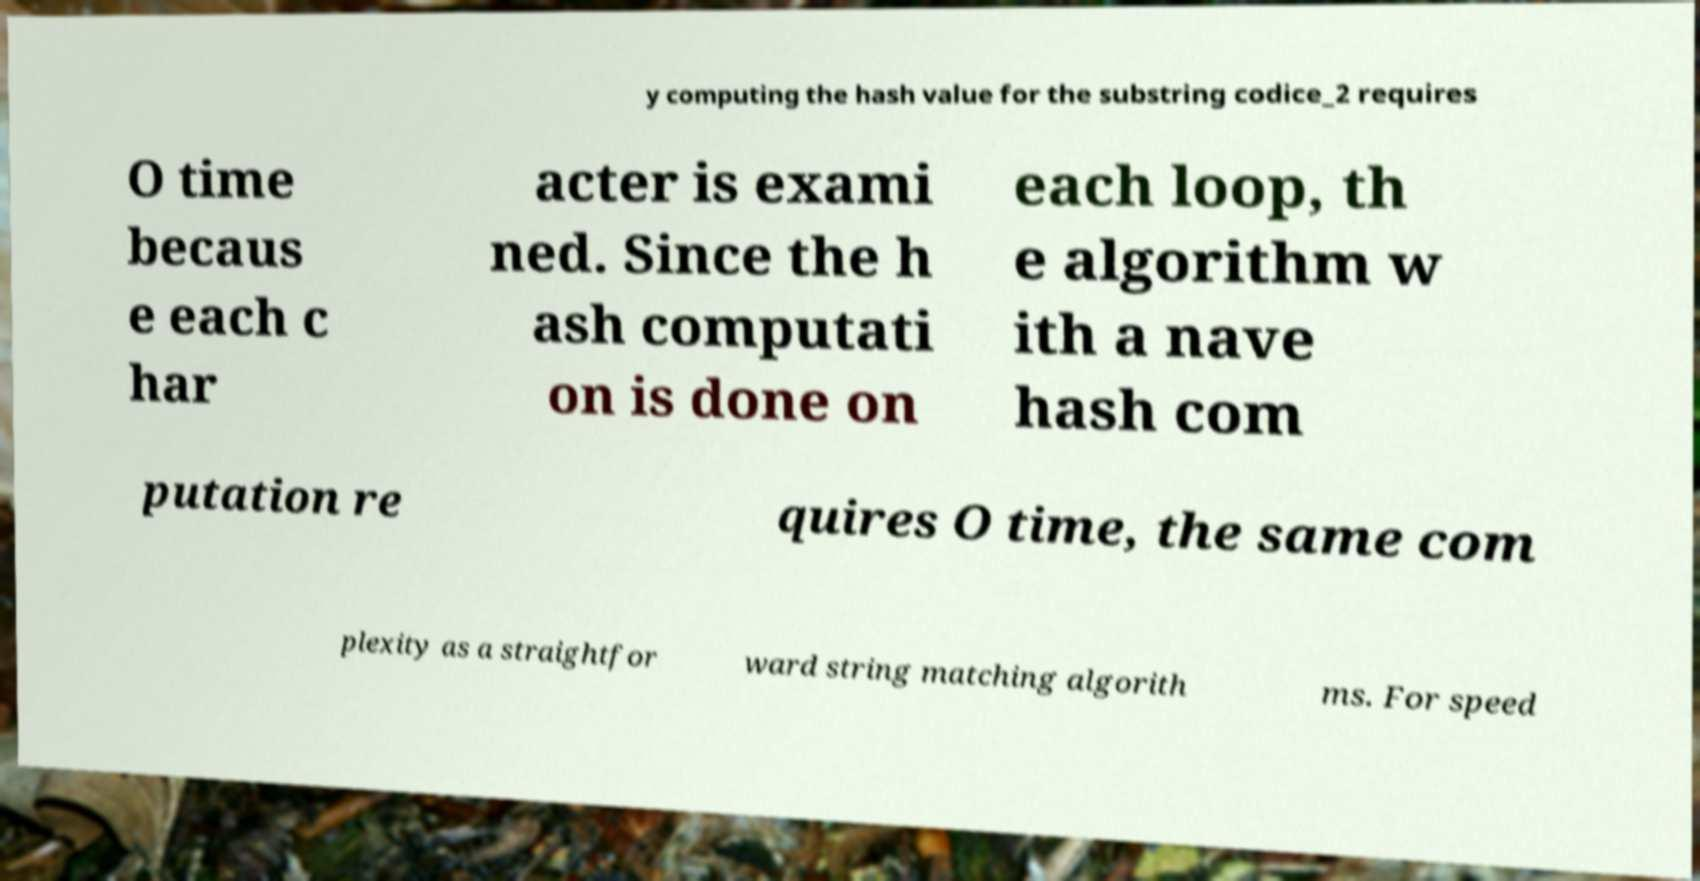Could you assist in decoding the text presented in this image and type it out clearly? y computing the hash value for the substring codice_2 requires O time becaus e each c har acter is exami ned. Since the h ash computati on is done on each loop, th e algorithm w ith a nave hash com putation re quires O time, the same com plexity as a straightfor ward string matching algorith ms. For speed 